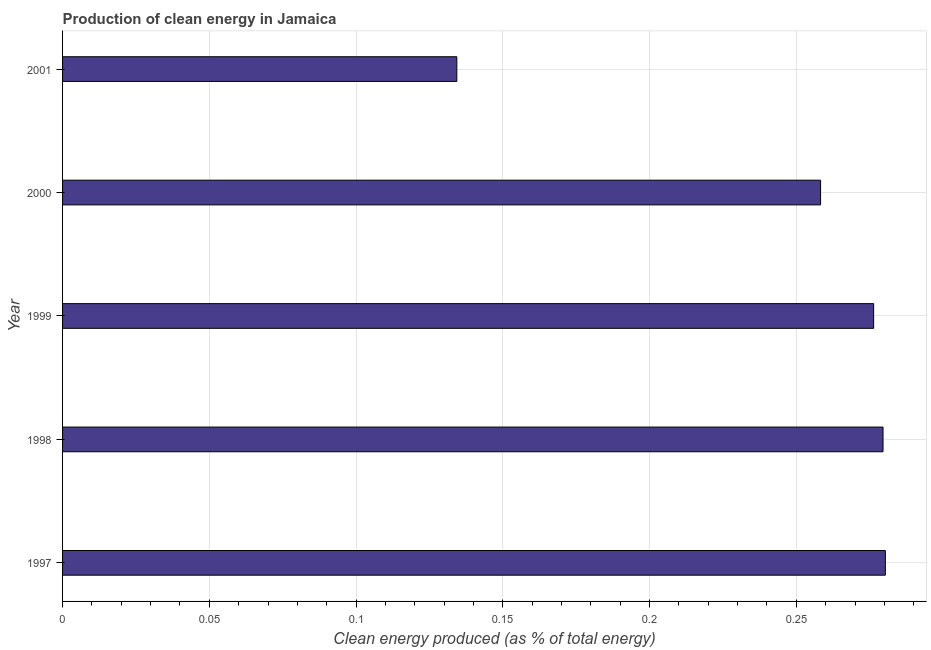Does the graph contain any zero values?
Give a very brief answer. No. Does the graph contain grids?
Offer a terse response. Yes. What is the title of the graph?
Make the answer very short. Production of clean energy in Jamaica. What is the label or title of the X-axis?
Provide a short and direct response. Clean energy produced (as % of total energy). What is the production of clean energy in 1997?
Give a very brief answer. 0.28. Across all years, what is the maximum production of clean energy?
Provide a short and direct response. 0.28. Across all years, what is the minimum production of clean energy?
Provide a succinct answer. 0.13. In which year was the production of clean energy maximum?
Provide a succinct answer. 1997. In which year was the production of clean energy minimum?
Offer a very short reply. 2001. What is the sum of the production of clean energy?
Make the answer very short. 1.23. What is the difference between the production of clean energy in 1997 and 1999?
Provide a short and direct response. 0. What is the average production of clean energy per year?
Give a very brief answer. 0.25. What is the median production of clean energy?
Keep it short and to the point. 0.28. What is the ratio of the production of clean energy in 1997 to that in 2000?
Your answer should be compact. 1.08. Is the difference between the production of clean energy in 1998 and 2001 greater than the difference between any two years?
Provide a short and direct response. No. What is the difference between the highest and the second highest production of clean energy?
Make the answer very short. 0. How many bars are there?
Your answer should be compact. 5. Are all the bars in the graph horizontal?
Keep it short and to the point. Yes. Are the values on the major ticks of X-axis written in scientific E-notation?
Your answer should be very brief. No. What is the Clean energy produced (as % of total energy) in 1997?
Ensure brevity in your answer.  0.28. What is the Clean energy produced (as % of total energy) in 1998?
Your answer should be compact. 0.28. What is the Clean energy produced (as % of total energy) of 1999?
Keep it short and to the point. 0.28. What is the Clean energy produced (as % of total energy) in 2000?
Provide a succinct answer. 0.26. What is the Clean energy produced (as % of total energy) in 2001?
Make the answer very short. 0.13. What is the difference between the Clean energy produced (as % of total energy) in 1997 and 1998?
Provide a short and direct response. 0. What is the difference between the Clean energy produced (as % of total energy) in 1997 and 1999?
Keep it short and to the point. 0. What is the difference between the Clean energy produced (as % of total energy) in 1997 and 2000?
Your answer should be compact. 0.02. What is the difference between the Clean energy produced (as % of total energy) in 1997 and 2001?
Your answer should be compact. 0.15. What is the difference between the Clean energy produced (as % of total energy) in 1998 and 1999?
Provide a short and direct response. 0. What is the difference between the Clean energy produced (as % of total energy) in 1998 and 2000?
Provide a short and direct response. 0.02. What is the difference between the Clean energy produced (as % of total energy) in 1998 and 2001?
Make the answer very short. 0.15. What is the difference between the Clean energy produced (as % of total energy) in 1999 and 2000?
Offer a terse response. 0.02. What is the difference between the Clean energy produced (as % of total energy) in 1999 and 2001?
Offer a terse response. 0.14. What is the difference between the Clean energy produced (as % of total energy) in 2000 and 2001?
Provide a succinct answer. 0.12. What is the ratio of the Clean energy produced (as % of total energy) in 1997 to that in 1998?
Offer a very short reply. 1. What is the ratio of the Clean energy produced (as % of total energy) in 1997 to that in 1999?
Your answer should be compact. 1.01. What is the ratio of the Clean energy produced (as % of total energy) in 1997 to that in 2000?
Your answer should be very brief. 1.08. What is the ratio of the Clean energy produced (as % of total energy) in 1997 to that in 2001?
Your response must be concise. 2.09. What is the ratio of the Clean energy produced (as % of total energy) in 1998 to that in 2000?
Provide a succinct answer. 1.08. What is the ratio of the Clean energy produced (as % of total energy) in 1998 to that in 2001?
Keep it short and to the point. 2.08. What is the ratio of the Clean energy produced (as % of total energy) in 1999 to that in 2000?
Offer a very short reply. 1.07. What is the ratio of the Clean energy produced (as % of total energy) in 1999 to that in 2001?
Keep it short and to the point. 2.06. What is the ratio of the Clean energy produced (as % of total energy) in 2000 to that in 2001?
Provide a short and direct response. 1.92. 